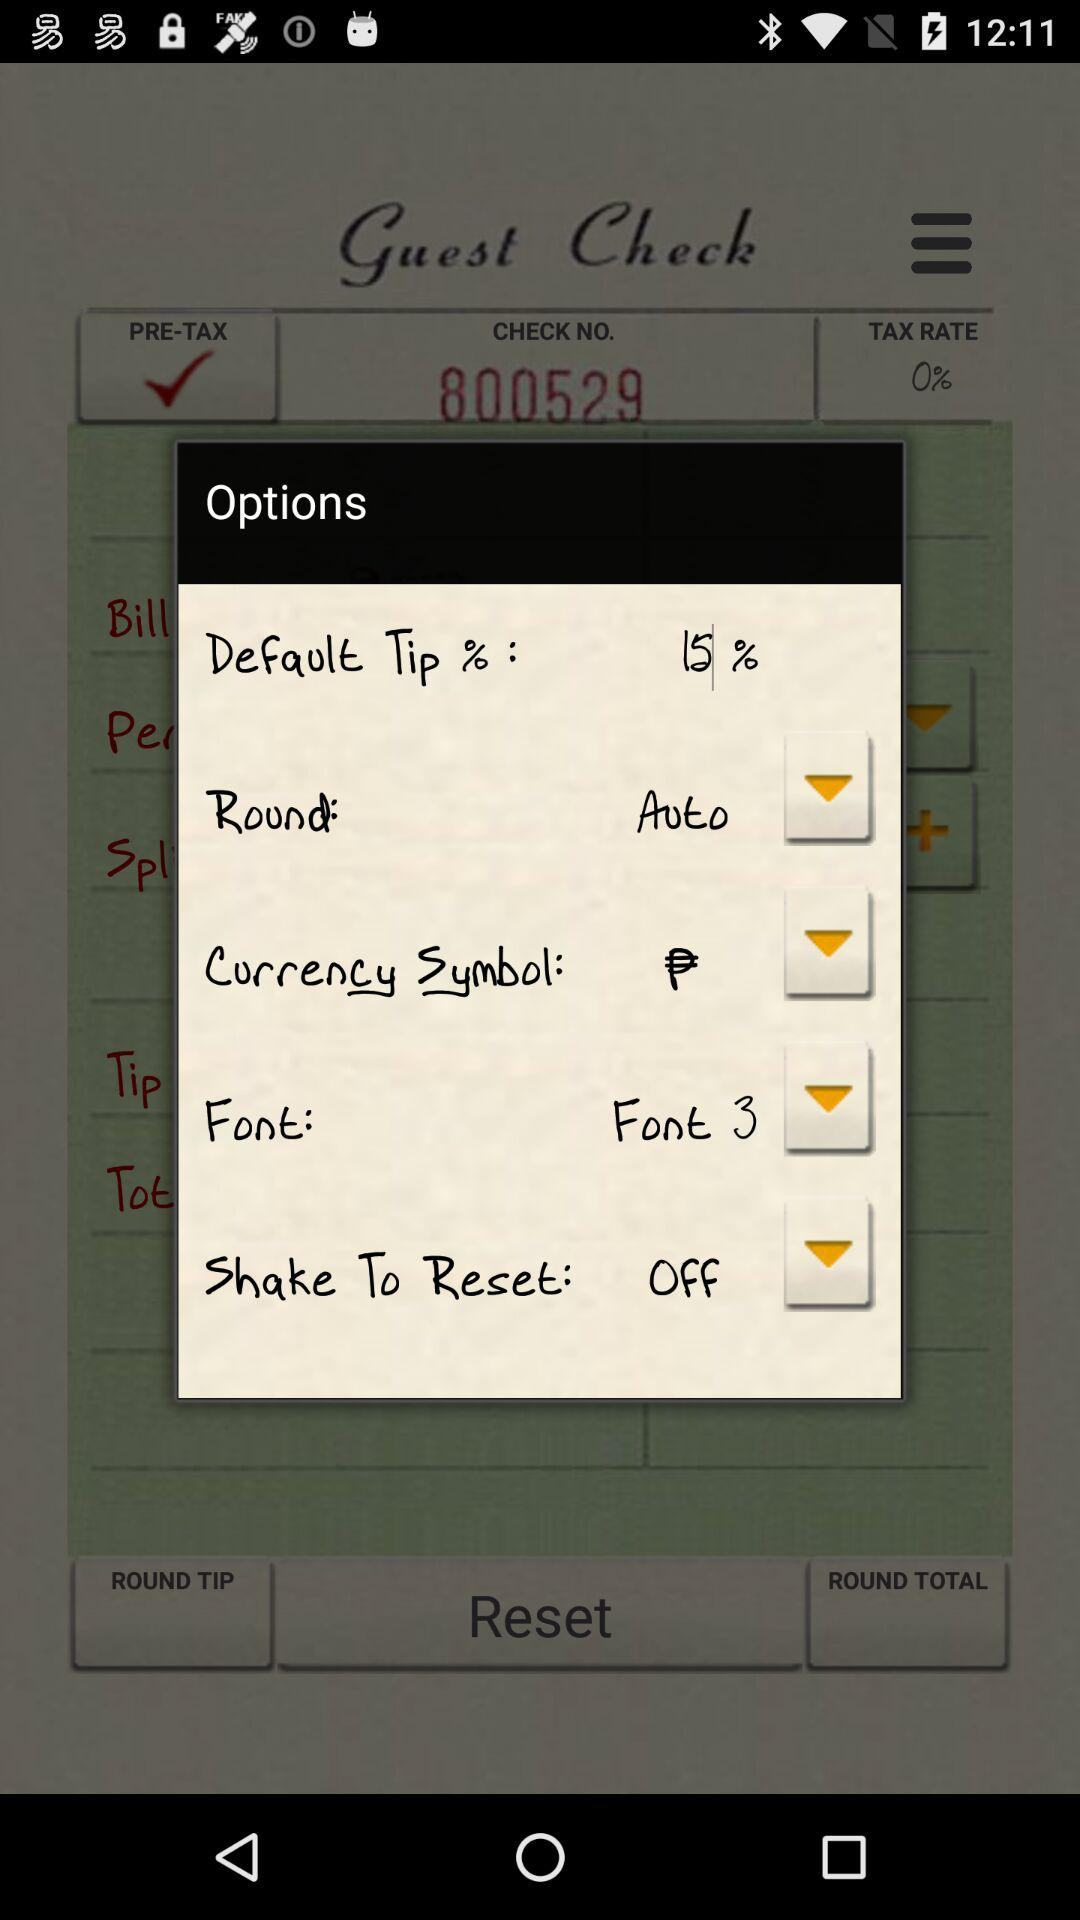How many downward arrows are in the options menu?
Answer the question using a single word or phrase. 4 